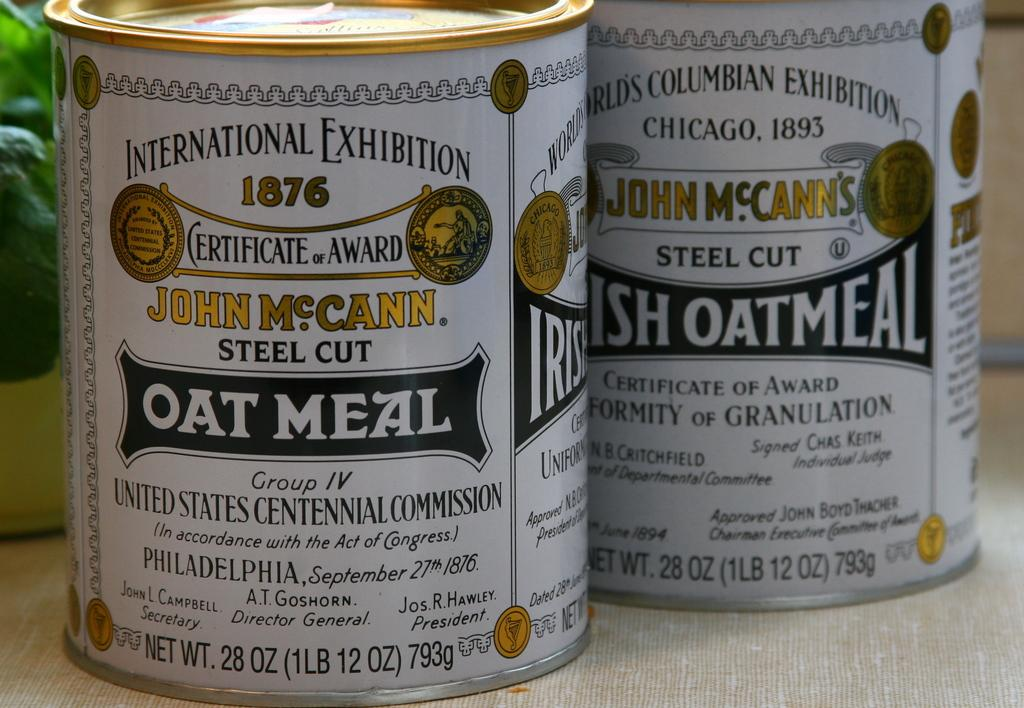Provide a one-sentence caption for the provided image. Two cans of John McCann's steel cut oat meal sit on a counter. 